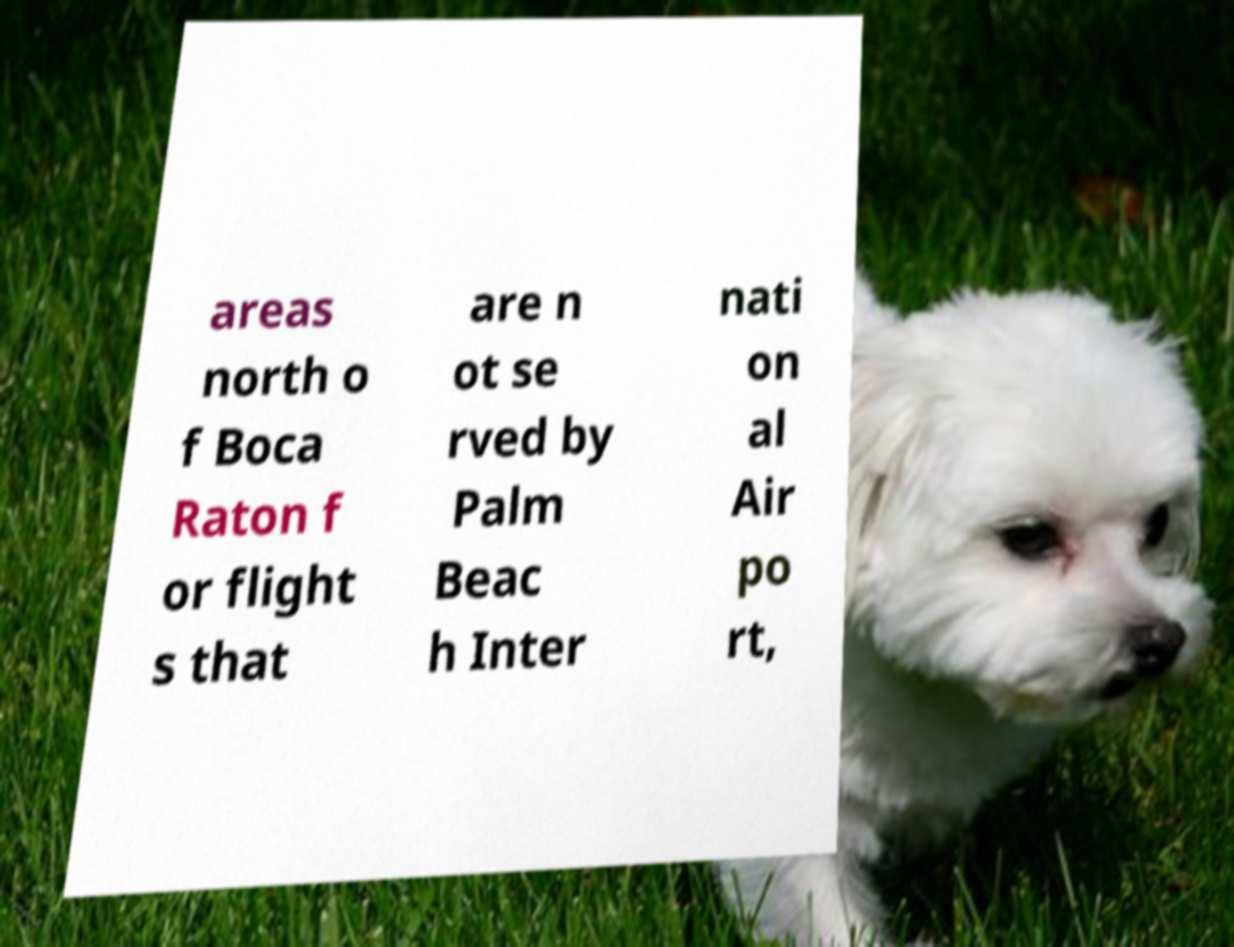There's text embedded in this image that I need extracted. Can you transcribe it verbatim? areas north o f Boca Raton f or flight s that are n ot se rved by Palm Beac h Inter nati on al Air po rt, 